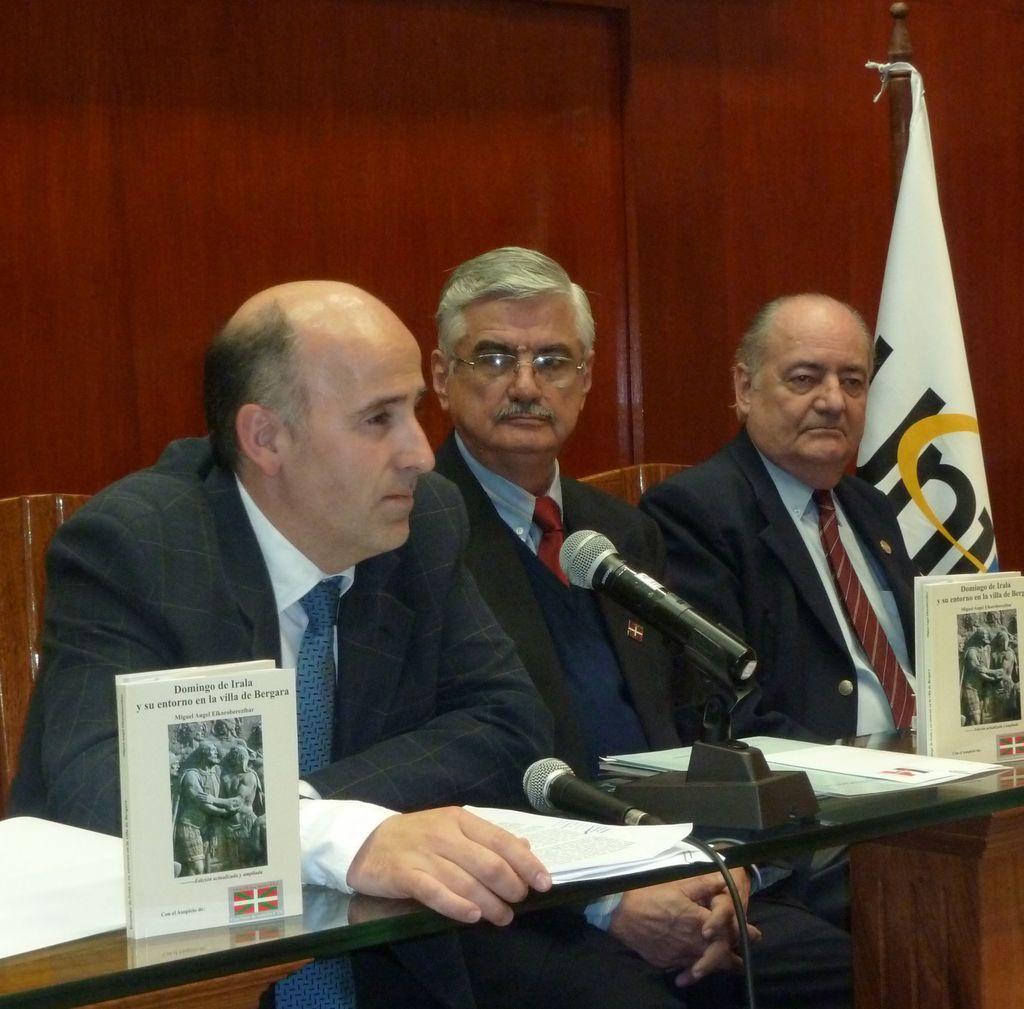Describe this image in one or two sentences. In this image I can see three men are sitting and I can see all of them are wearing formal dress. In the front of them I can see a table and on it I can see few white colour papers, few books and two mics. On the right side of this image I can see a white colour flag. 